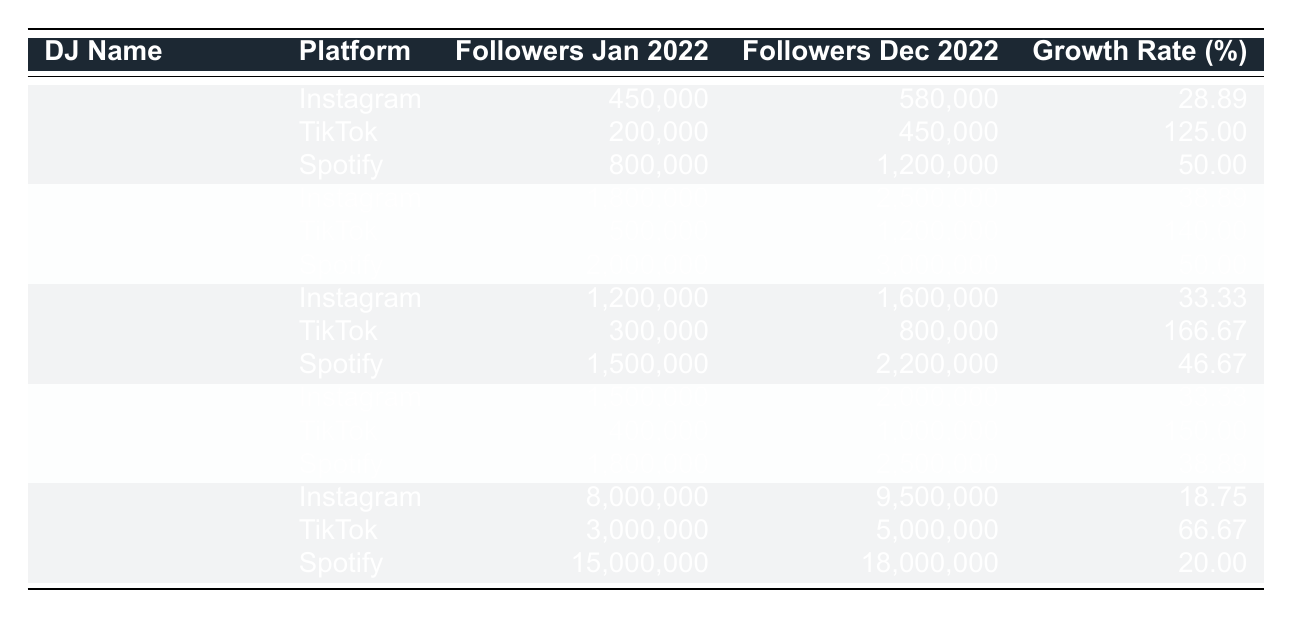What is the highest growth rate among the DJs on Instagram? Looking at the growth rates for each DJ on Instagram, REZZ has a growth rate of 28.89%, Peggy Gou has 38.89%, Amelie Lens has 33.33%, Charlotte de Witte also has 33.33%, and Zedd has 18.75%. The highest is Peggy Gou with 38.89%.
Answer: 38.89% Which DJ had the most significant follower growth on TikTok? On TikTok, REZZ had a growth rate of 125.00%, Peggy Gou had 140.00%, Amelie Lens had 166.67%, Charlotte de Witte had 150.00%, and Zedd had 66.67%. Amelie Lens had the most significant growth at 166.67%.
Answer: 166.67% Did Zedd experience a higher follower growth rate on Spotify compared to Instagram? Zedd's growth rate on Spotify is 20.00%, while on Instagram it is 18.75%. Since 20.00% is higher than 18.75%, the statement is true.
Answer: Yes What is the average follower growth rate across all DJs on Spotify? The growth rates for Spotify are 50.00% (REZZ), 50.00% (Peggy Gou), 46.67% (Amelie Lens), 38.89% (Charlotte de Witte), and 20.00% (Zedd). The sum is 50.00 + 50.00 + 46.67 + 38.89 + 20.00 = 205.56, and dividing by 5 gives an average of 41.11%.
Answer: 41.11% Which platform had the highest overall growth rates for emerging DJs? For Instagram, the highest growth is 38.89% (Peggy Gou), for TikTok, it's 166.67% (Amelie Lens), and for Spotify, it's 50.00% (REZZ and Peggy Gou). The highest overall is TikTok at 166.67%.
Answer: TikTok How much did Peggy Gou's follower count increase on TikTok in absolute numbers? Peggy Gou's follower count on TikTok increased from 500,000 to 1,200,000. The increase is 1,200,000 - 500,000 = 700,000.
Answer: 700,000 Which DJ had the lowest growth rate and on which platform? Zedd had the lowest growth rate of 18.75% on Instagram. Comparing all growth rates, this is the minimum.
Answer: 18.75% on Instagram What is the total follower count for REZZ across all platforms by December 2022? By December 2022, the follower counts for REZZ are 580,000 (Instagram), 450,000 (TikTok), and 1,200,000 (Spotify). Summing these gives 580,000 + 450,000 + 1,200,000 = 2,230,000.
Answer: 2,230,000 Did any DJ have a consistent growth rate across all platforms? Analyzing the growth rates across platforms, REZZ has 28.89%, 125.00%, and 50.00%, while Peggy Gou has 38.89%, 140.00%, and 50.00%. None of them had consistent growth rates across all platforms.
Answer: No 